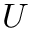<formula> <loc_0><loc_0><loc_500><loc_500>U</formula> 